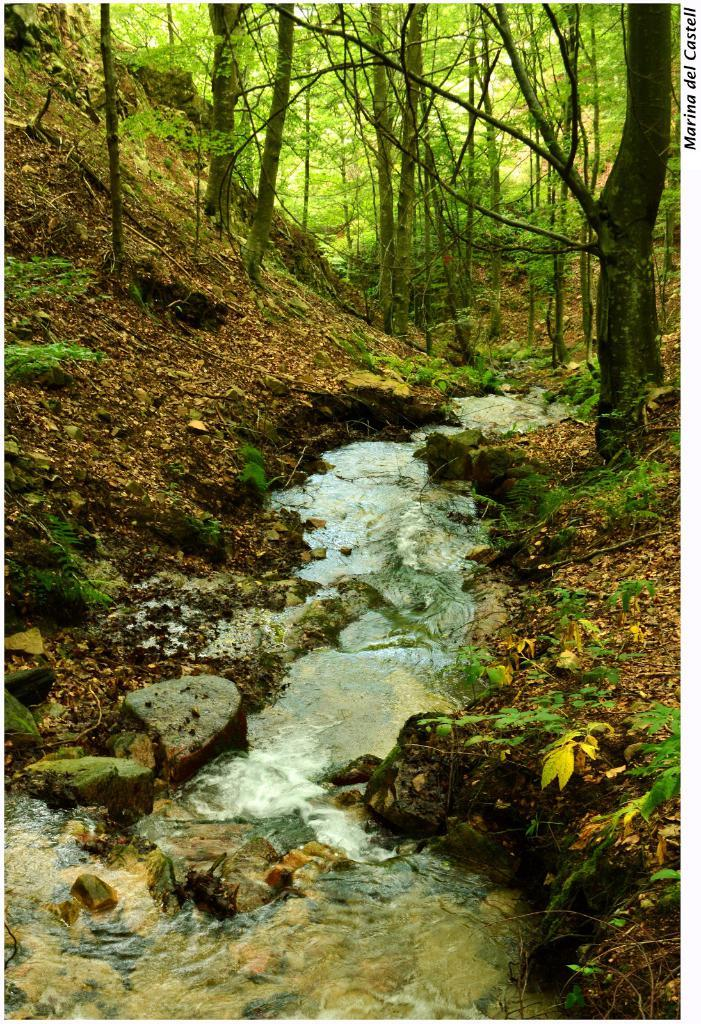What type of natural environment is depicted in the image? The image contains a forest area. What body of water can be seen in the image? There is a flowing river in the image. What type of sand can be seen on the riverbank in the image? There is no sand visible in the image; it features a forest area and a flowing river. 